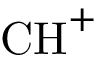Convert formula to latex. <formula><loc_0><loc_0><loc_500><loc_500>C H ^ { + }</formula> 